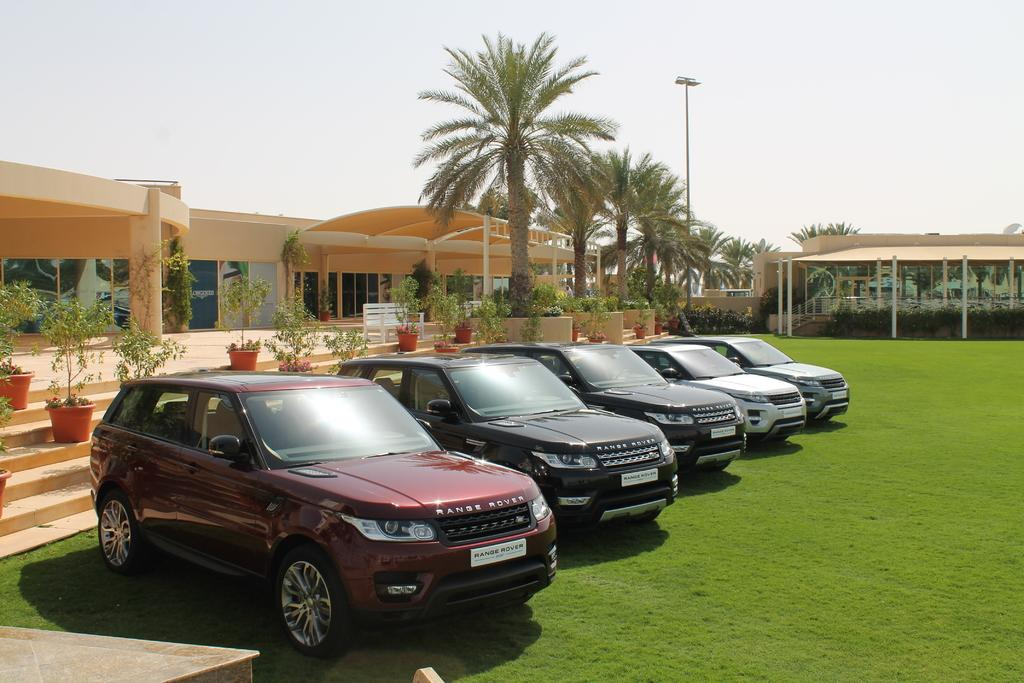What is located on the ground in the image? There are vehicles on the ground in the image. What can be seen in the background of the image? In the background of the image, there are plants in pots, buildings, trees, and the sky. Can you describe the setting of the image? The image shows vehicles on the ground, with plants in pots, buildings, trees, and the sky visible in the background. What type of feast is being prepared in the cellar in the image? There is no cellar or feast present in the image. What color is the yarn used to decorate the trees in the image? There is no yarn or decoration on the trees in the image. 